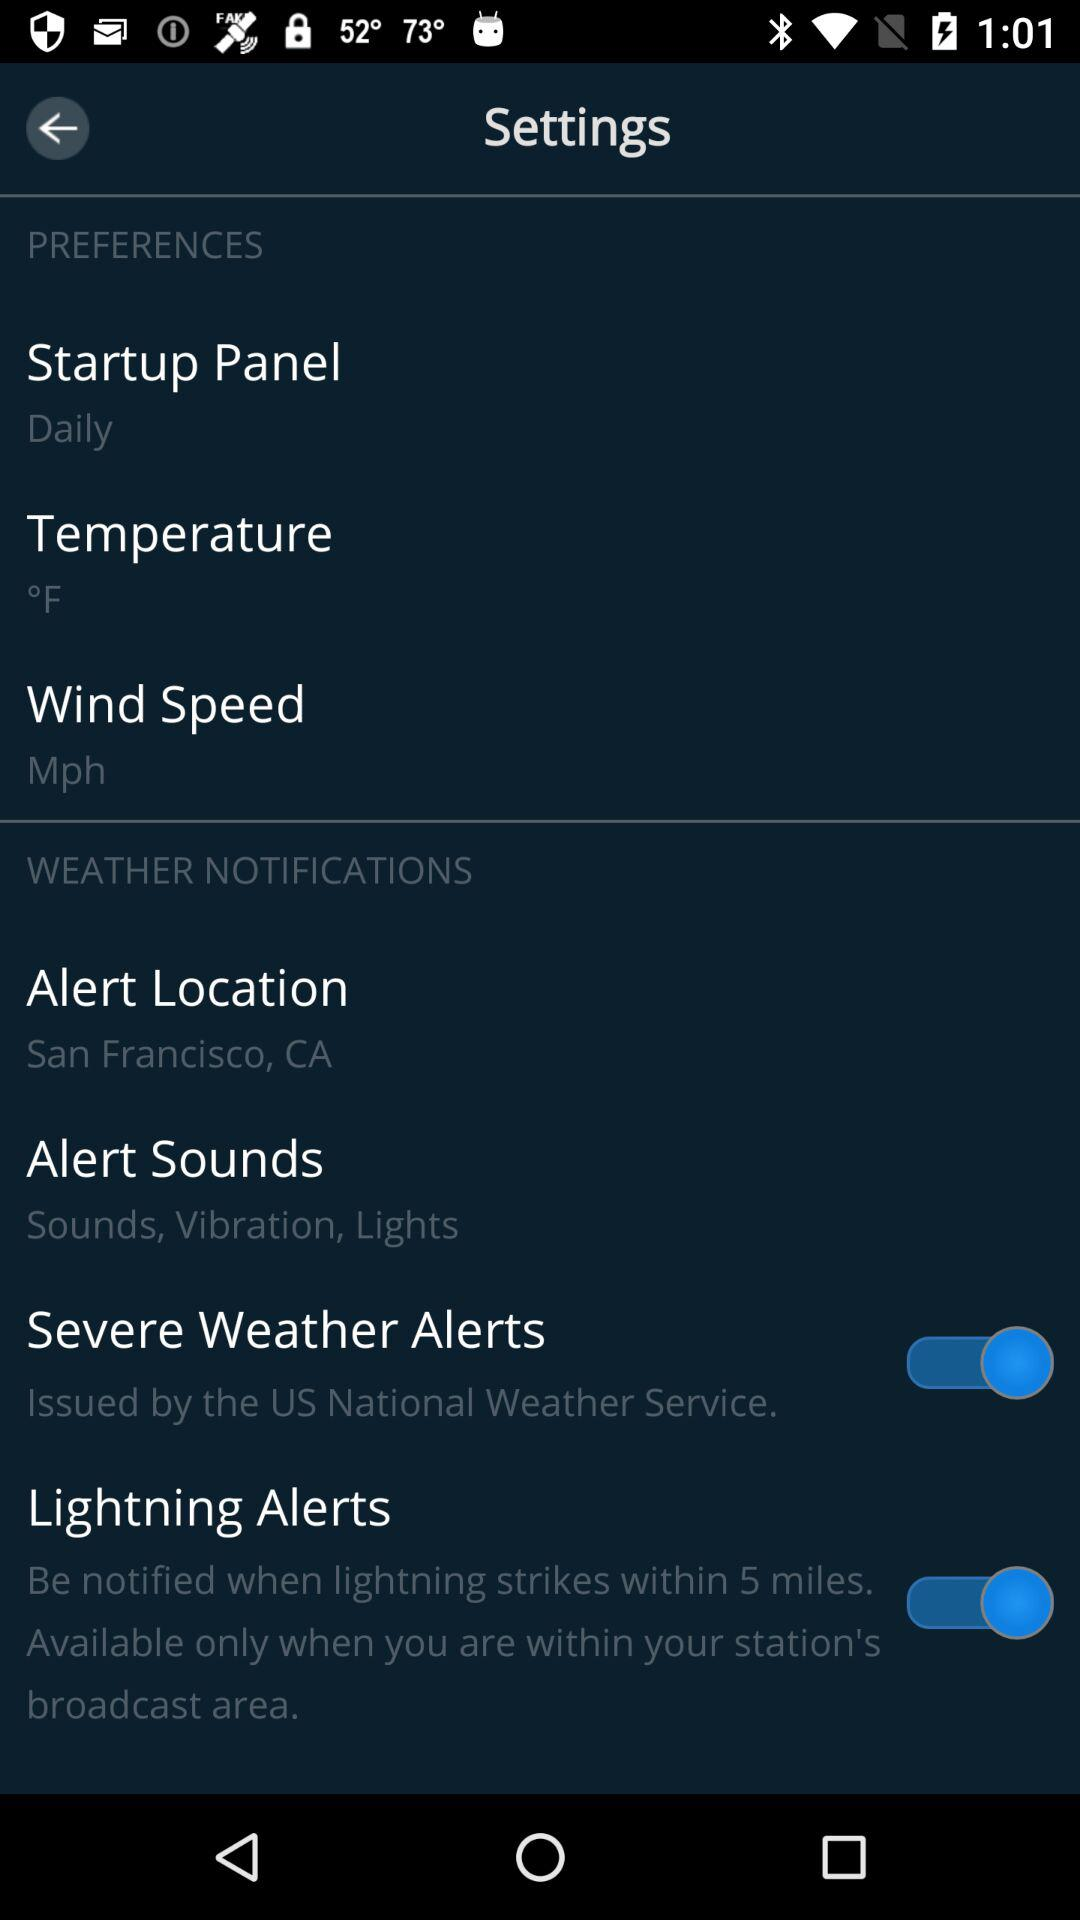What is the alert location? The alert location is San Francisco, CA. 